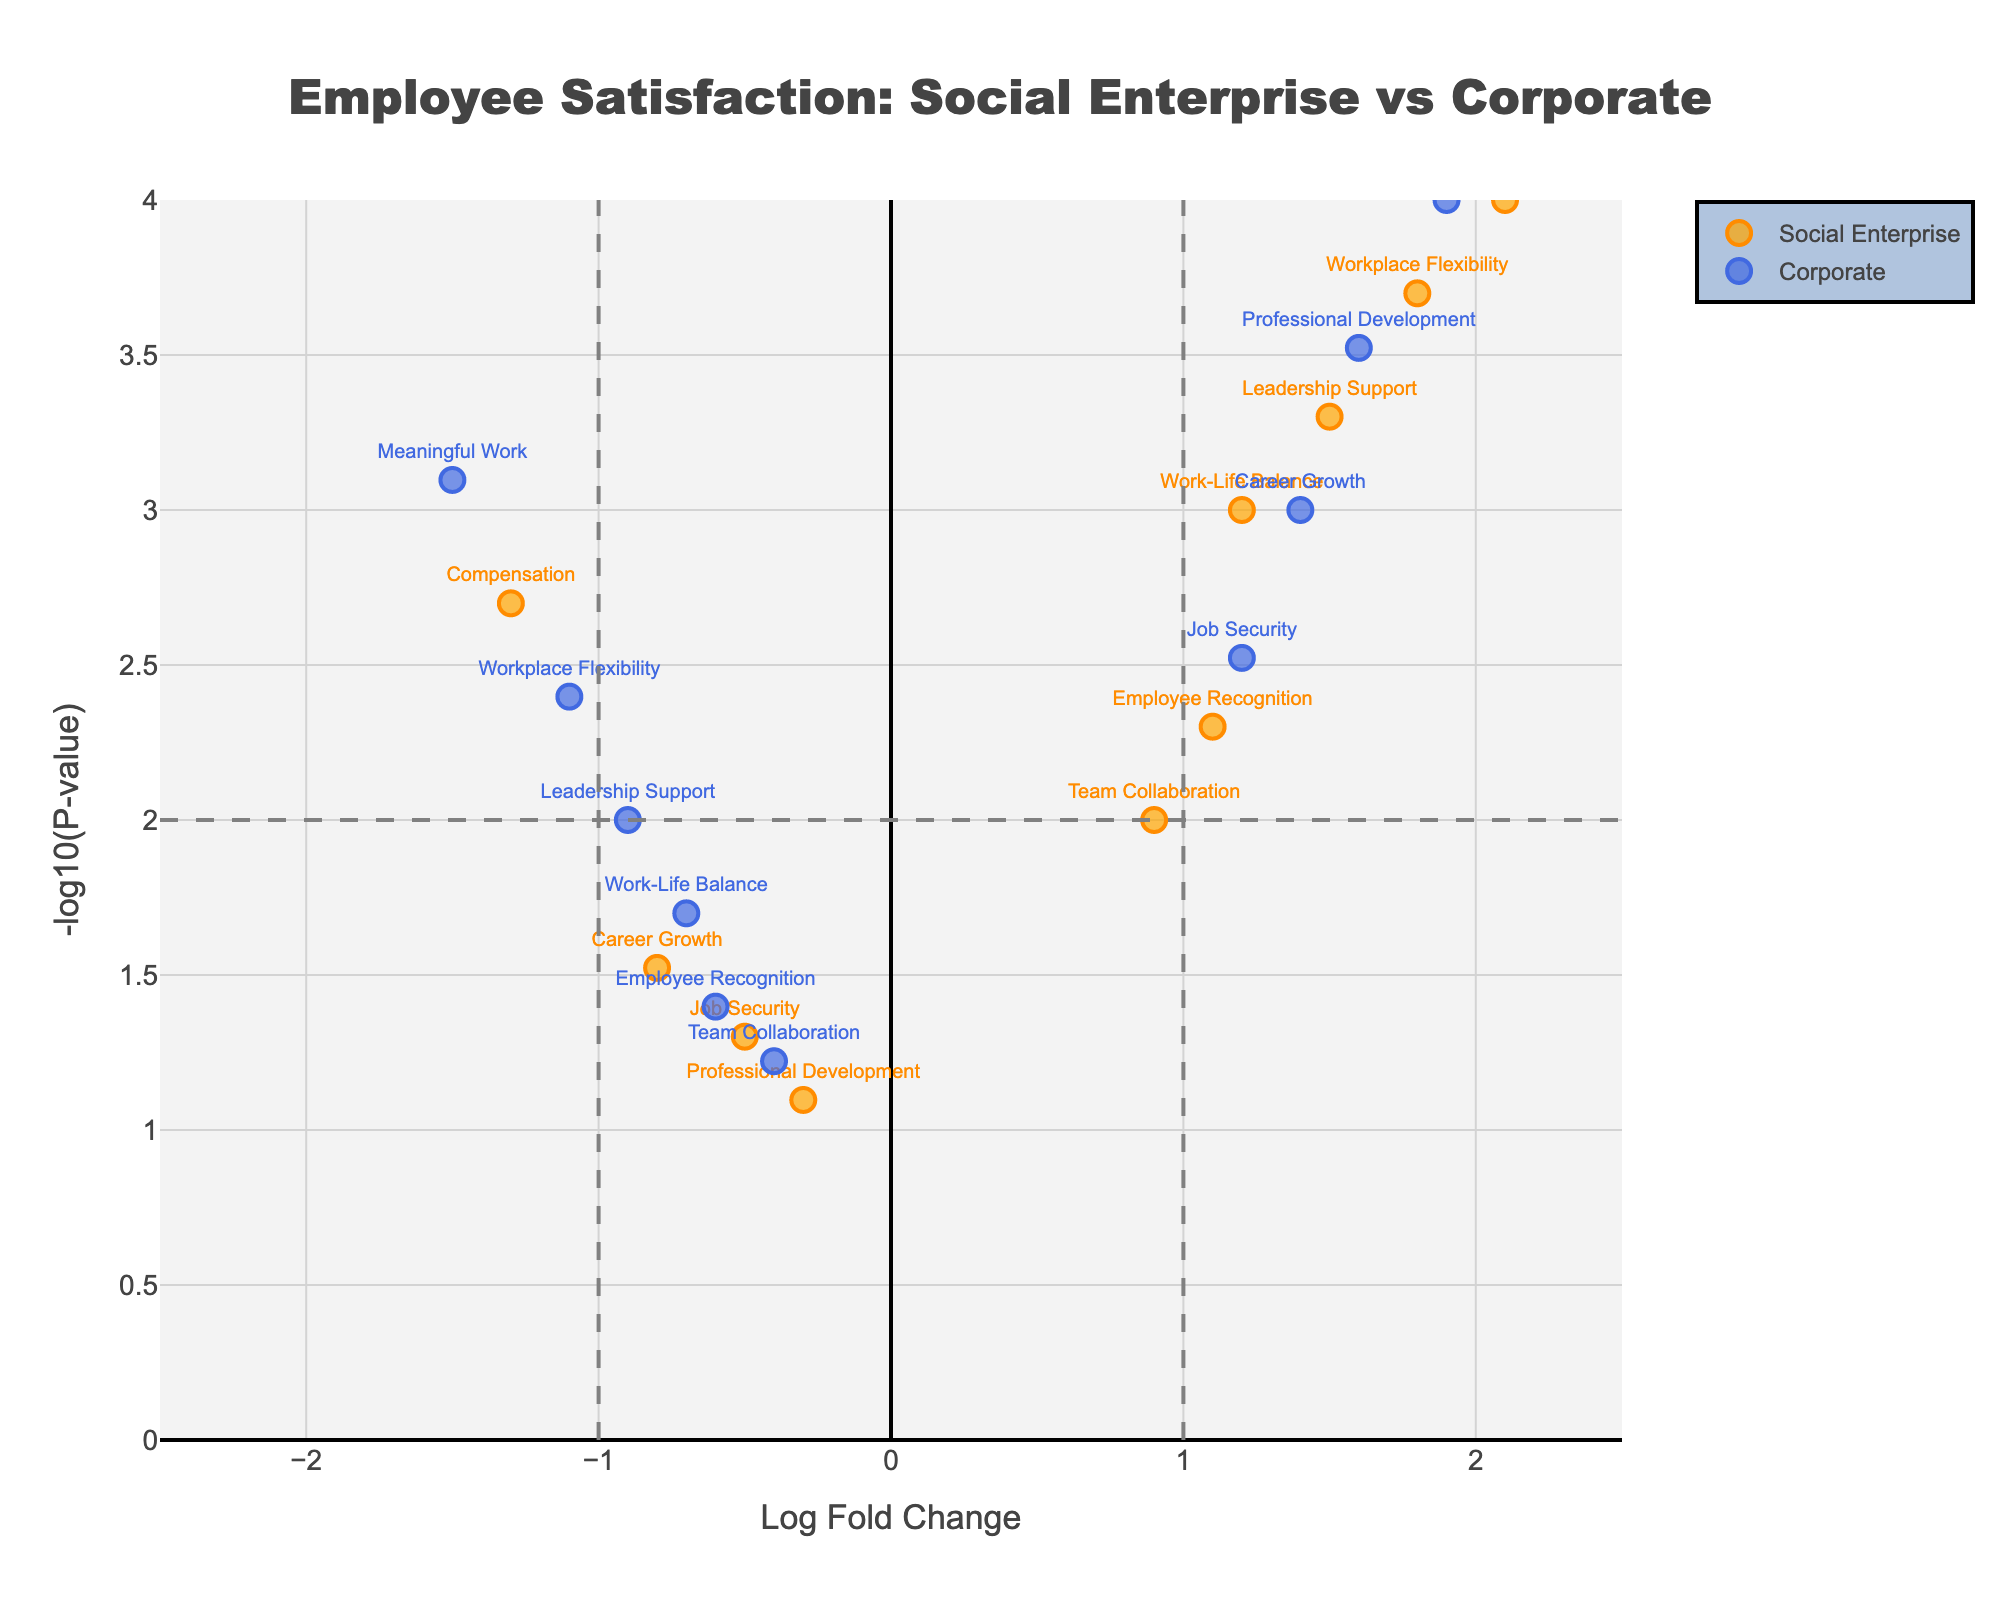What is the title of the figure? The title of the figure is displayed at the top center of the plot, which reads "Employee Satisfaction: Social Enterprise vs Corporate".
Answer: Employee Satisfaction: Social Enterprise vs Corporate How many data points represent Social Enterprises in the plot? The Social Enterprise data points can be identified by their orange color. By counting, we can see there are 10 points for Social Enterprises.
Answer: 10 Which employee satisfaction factor shows the highest log fold change in Social Enterprises? By examining the x-axis values for the Social Enterprise data points, the highest log fold change is associated with "Meaningful Work" at LogFC = 2.1.
Answer: Meaningful Work Which employee satisfaction factor has the smallest p-value in Corporate environments? The smallest p-value corresponds to the highest y-axis value. In the Corporate trace, "Compensation" has the highest y-coordinate value, indicating the smallest p-value.
Answer: Compensation How do "Work-Life Balance" in Social Enterprises and "Work-Life Balance" in Corporate environments compare in terms of log fold change? The log fold change for "Work-Life Balance" in Social Enterprises is 1.2, while in Corporate environments it is -0.7. Hence, it is higher in Social Enterprises.
Answer: Higher in Social Enterprises Which factor has a higher significance (more significant p-value), "Leadership Support" in Social Enterprises or "Leadership Support" in Corporate environments? The p-value for "Leadership Support" in Social Enterprises is represented by its y-value (-log10(0.0005) ≈ 3.3), which is higher than in Corporate environments (-log10(0.01) ≈ 2). Higher y-value means more significant p-value, hence "Leadership Support" in Social Enterprises is more significant.
Answer: Leadership Support in Social Enterprises What is the general trend in terms of compensation between Social Enterprises and Corporate environments? The LogFC for "Compensation" is -1.3 for Social Enterprises and 1.9 for Corporate environments. This indicates that compensation scores much higher in Corporate environments compared to Social Enterprises.
Answer: Higher in Corporate environments Which Enterprise Type seemingly places more emphasis on "Workplace Flexibility" based on Log Fold Change? In Social Enterprises, the LogFC for "Workplace Flexibility" is 1.8 while in Corporate environments it is -1.1, indicating a strong emphasis in Social Enterprises compared to Corporate environments.
Answer: Social Enterprises For Social Enterprises, what proportion of data points have a statistically significant p-value (p<0.05)? There are 10 data points representing Social Enterprises. By counting the points with y-values greater than -log10(0.05) ≈ 1.3, we find 8 points are statistically significant out of the 10 total. Therefore, 8/10 = 0.8 or 80% of the points are significant.
Answer: 80% What factors in Corporate environments have negative log fold changes? By inspecting the Corporate data points that have negative x-axis values (LogFC < 0), the factors are "Work-Life Balance", "Meaningful Work", "Team Collaboration", "Leadership Support", "Workplace Flexibility", and "Employee Recognition".
Answer: 6 factors: Work-Life Balance, Meaningful Work, Team Collaboration, Leadership Support, Workplace Flexibility, Employee Recognition 